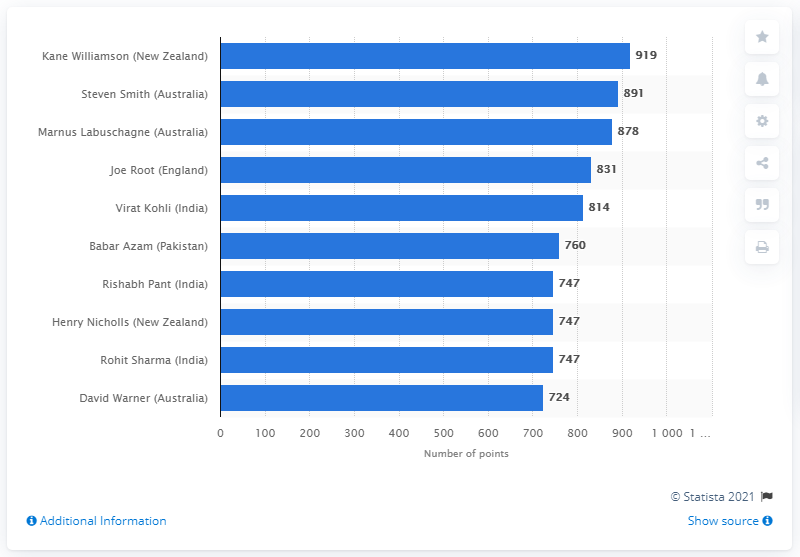Identify some key points in this picture. Kane Williamson has a total of 919 points. 